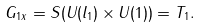Convert formula to latex. <formula><loc_0><loc_0><loc_500><loc_500>G _ { 1 x } = S ( U ( l _ { 1 } ) \times U ( 1 ) ) = T _ { 1 } .</formula> 